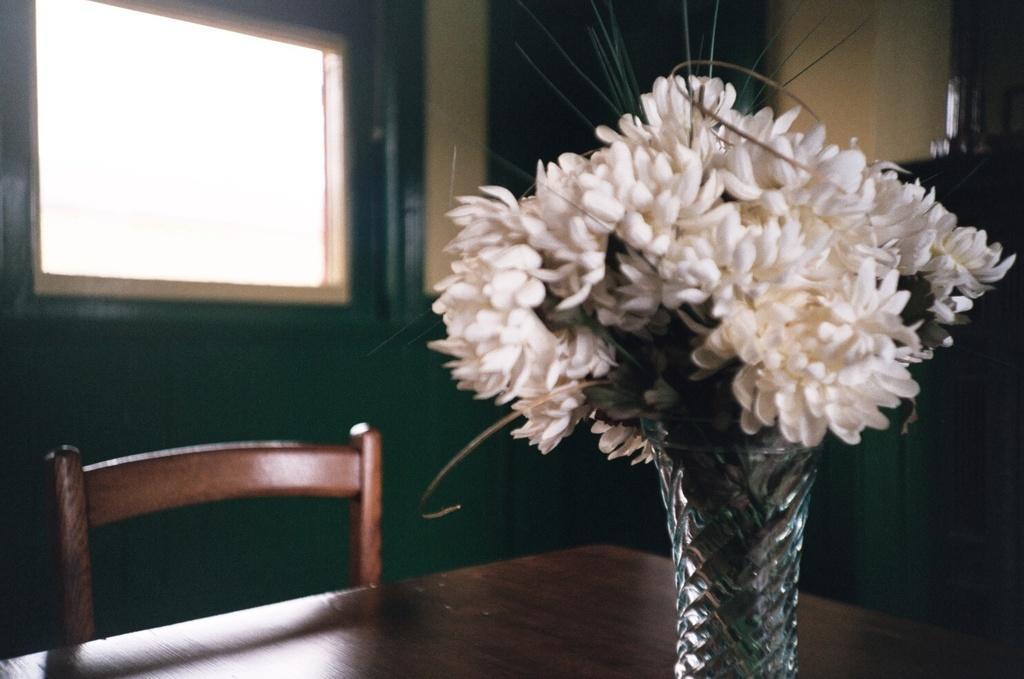Could you give a brief overview of what you see in this image? In the middle there is a table on that there is a flower vase ,In front of the table there is a chair. In the background there is a window and wall 